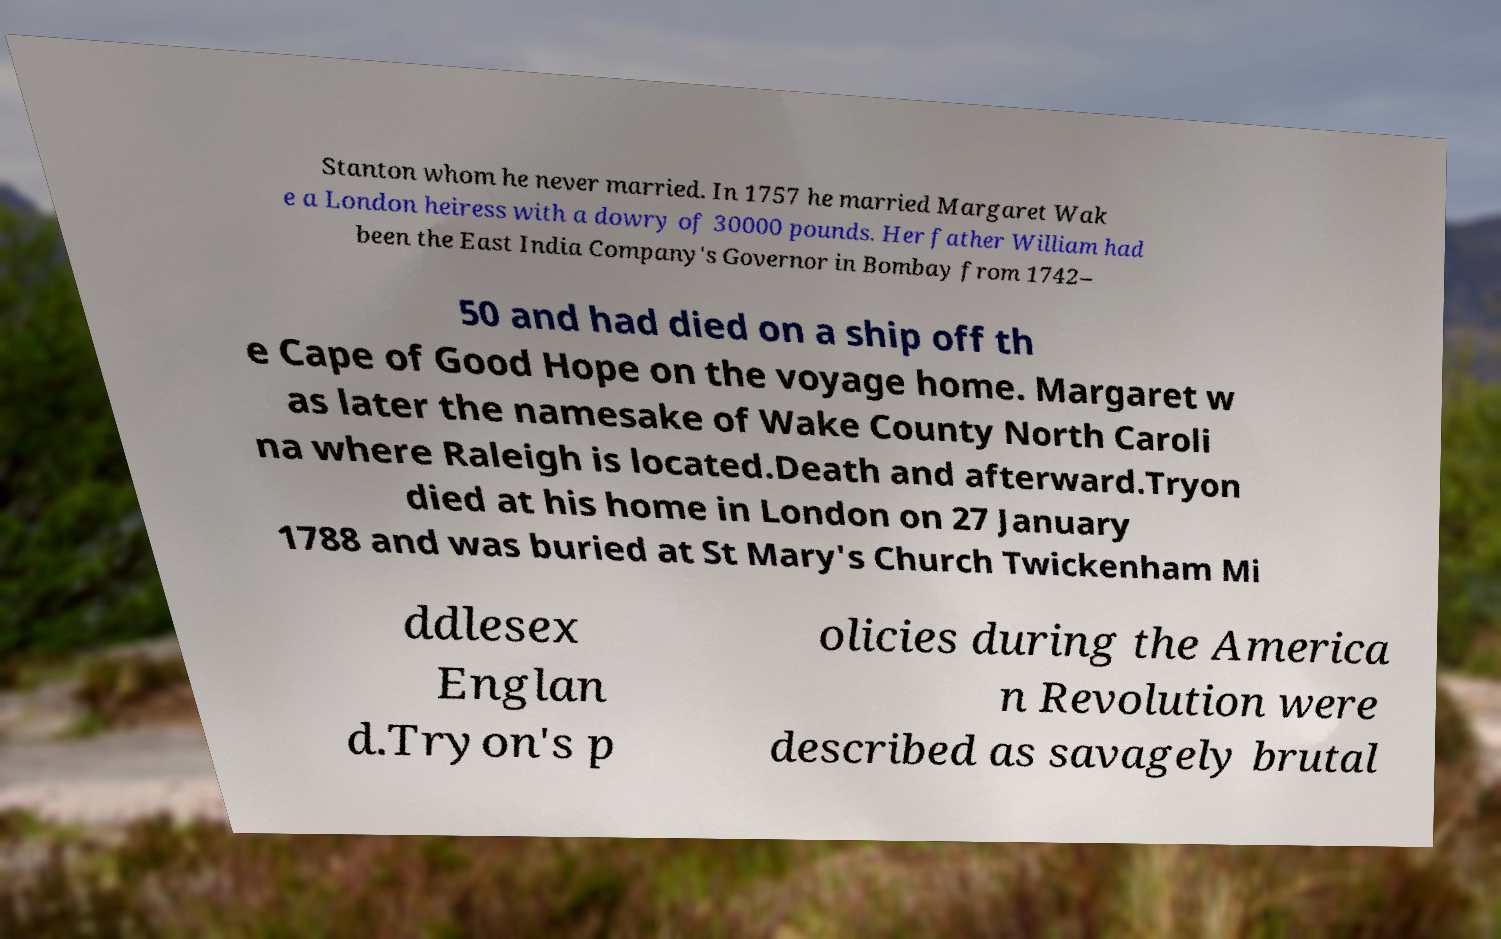For documentation purposes, I need the text within this image transcribed. Could you provide that? Stanton whom he never married. In 1757 he married Margaret Wak e a London heiress with a dowry of 30000 pounds. Her father William had been the East India Company's Governor in Bombay from 1742– 50 and had died on a ship off th e Cape of Good Hope on the voyage home. Margaret w as later the namesake of Wake County North Caroli na where Raleigh is located.Death and afterward.Tryon died at his home in London on 27 January 1788 and was buried at St Mary's Church Twickenham Mi ddlesex Englan d.Tryon's p olicies during the America n Revolution were described as savagely brutal 